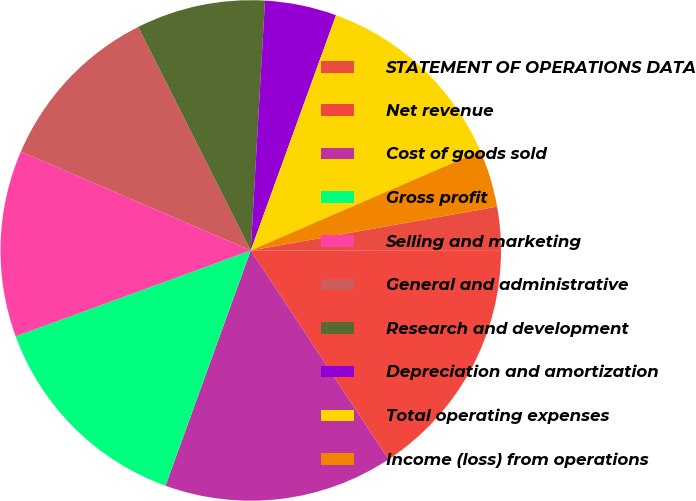<chart> <loc_0><loc_0><loc_500><loc_500><pie_chart><fcel>STATEMENT OF OPERATIONS DATA<fcel>Net revenue<fcel>Cost of goods sold<fcel>Gross profit<fcel>Selling and marketing<fcel>General and administrative<fcel>Research and development<fcel>Depreciation and amortization<fcel>Total operating expenses<fcel>Income (loss) from operations<nl><fcel>2.78%<fcel>15.74%<fcel>14.81%<fcel>13.89%<fcel>12.04%<fcel>11.11%<fcel>8.33%<fcel>4.63%<fcel>12.96%<fcel>3.7%<nl></chart> 